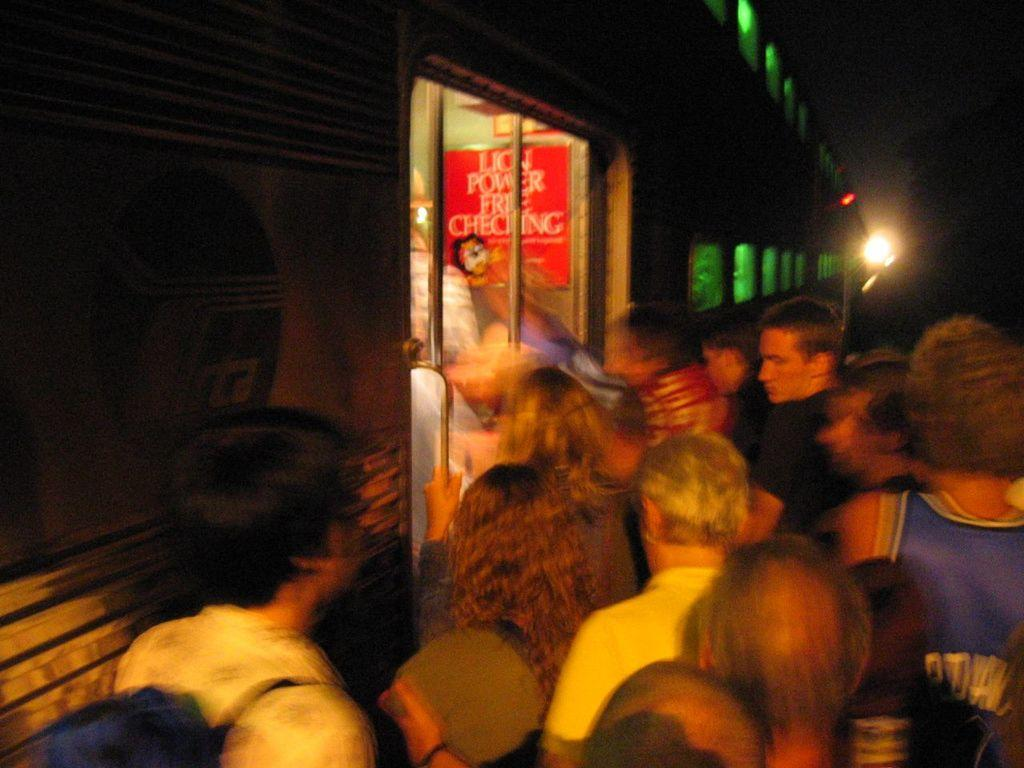Who or what is present in the image? There are people in the image. What else can be seen in the image besides the people? There is a vehicle, a poster, and a light in the image. Can you describe the background of the image? The background of the image is dark. What type of debt is being discussed in the image? There is no mention of debt in the image; it features people, a vehicle, a poster, and a light. Can you tell me how many eggs are in the eggnog being served in the image? There is no eggnog present in the image. 